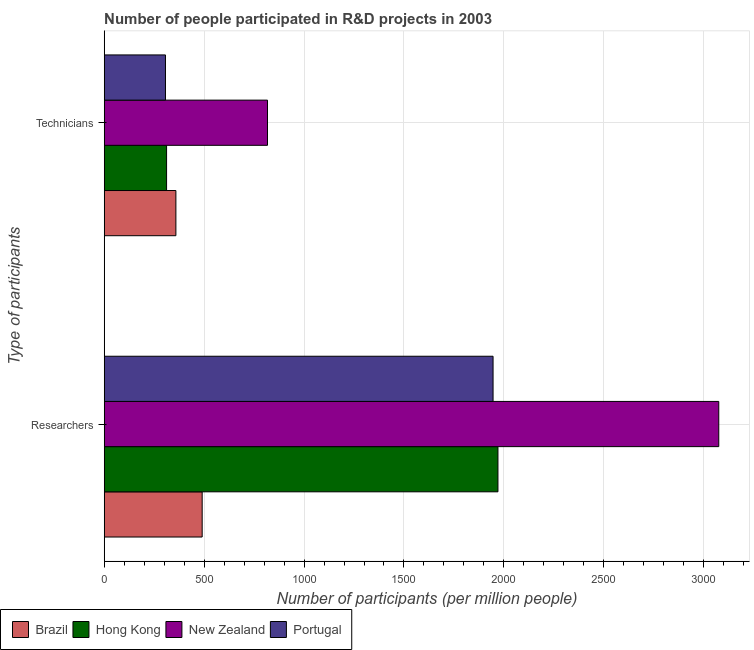How many different coloured bars are there?
Offer a very short reply. 4. Are the number of bars per tick equal to the number of legend labels?
Keep it short and to the point. Yes. What is the label of the 1st group of bars from the top?
Give a very brief answer. Technicians. What is the number of technicians in Brazil?
Make the answer very short. 358.64. Across all countries, what is the maximum number of technicians?
Provide a short and direct response. 817.12. Across all countries, what is the minimum number of researchers?
Ensure brevity in your answer.  490.22. In which country was the number of researchers maximum?
Give a very brief answer. New Zealand. In which country was the number of technicians minimum?
Offer a very short reply. Portugal. What is the total number of technicians in the graph?
Provide a short and direct response. 1794.44. What is the difference between the number of researchers in New Zealand and that in Brazil?
Ensure brevity in your answer.  2585. What is the difference between the number of technicians in Hong Kong and the number of researchers in Brazil?
Your answer should be very brief. -178.12. What is the average number of technicians per country?
Your answer should be compact. 448.61. What is the difference between the number of researchers and number of technicians in Brazil?
Keep it short and to the point. 131.58. What is the ratio of the number of technicians in Portugal to that in Hong Kong?
Make the answer very short. 0.98. Is the number of researchers in Brazil less than that in Hong Kong?
Your answer should be compact. Yes. What does the 3rd bar from the top in Technicians represents?
Provide a short and direct response. Hong Kong. What does the 3rd bar from the bottom in Researchers represents?
Provide a succinct answer. New Zealand. How many countries are there in the graph?
Give a very brief answer. 4. Does the graph contain grids?
Give a very brief answer. Yes. Where does the legend appear in the graph?
Make the answer very short. Bottom left. How are the legend labels stacked?
Your answer should be compact. Horizontal. What is the title of the graph?
Provide a short and direct response. Number of people participated in R&D projects in 2003. What is the label or title of the X-axis?
Provide a short and direct response. Number of participants (per million people). What is the label or title of the Y-axis?
Give a very brief answer. Type of participants. What is the Number of participants (per million people) of Brazil in Researchers?
Give a very brief answer. 490.22. What is the Number of participants (per million people) of Hong Kong in Researchers?
Make the answer very short. 1970.26. What is the Number of participants (per million people) in New Zealand in Researchers?
Your answer should be very brief. 3075.22. What is the Number of participants (per million people) of Portugal in Researchers?
Make the answer very short. 1945.82. What is the Number of participants (per million people) of Brazil in Technicians?
Your answer should be very brief. 358.64. What is the Number of participants (per million people) of Hong Kong in Technicians?
Offer a very short reply. 312.1. What is the Number of participants (per million people) in New Zealand in Technicians?
Provide a succinct answer. 817.12. What is the Number of participants (per million people) in Portugal in Technicians?
Ensure brevity in your answer.  306.57. Across all Type of participants, what is the maximum Number of participants (per million people) of Brazil?
Ensure brevity in your answer.  490.22. Across all Type of participants, what is the maximum Number of participants (per million people) in Hong Kong?
Provide a short and direct response. 1970.26. Across all Type of participants, what is the maximum Number of participants (per million people) of New Zealand?
Ensure brevity in your answer.  3075.22. Across all Type of participants, what is the maximum Number of participants (per million people) of Portugal?
Offer a very short reply. 1945.82. Across all Type of participants, what is the minimum Number of participants (per million people) in Brazil?
Make the answer very short. 358.64. Across all Type of participants, what is the minimum Number of participants (per million people) of Hong Kong?
Ensure brevity in your answer.  312.1. Across all Type of participants, what is the minimum Number of participants (per million people) of New Zealand?
Ensure brevity in your answer.  817.12. Across all Type of participants, what is the minimum Number of participants (per million people) in Portugal?
Offer a very short reply. 306.57. What is the total Number of participants (per million people) of Brazil in the graph?
Make the answer very short. 848.87. What is the total Number of participants (per million people) of Hong Kong in the graph?
Your response must be concise. 2282.36. What is the total Number of participants (per million people) of New Zealand in the graph?
Ensure brevity in your answer.  3892.35. What is the total Number of participants (per million people) of Portugal in the graph?
Your response must be concise. 2252.39. What is the difference between the Number of participants (per million people) of Brazil in Researchers and that in Technicians?
Provide a short and direct response. 131.58. What is the difference between the Number of participants (per million people) in Hong Kong in Researchers and that in Technicians?
Your response must be concise. 1658.16. What is the difference between the Number of participants (per million people) in New Zealand in Researchers and that in Technicians?
Offer a terse response. 2258.1. What is the difference between the Number of participants (per million people) in Portugal in Researchers and that in Technicians?
Keep it short and to the point. 1639.24. What is the difference between the Number of participants (per million people) in Brazil in Researchers and the Number of participants (per million people) in Hong Kong in Technicians?
Ensure brevity in your answer.  178.12. What is the difference between the Number of participants (per million people) of Brazil in Researchers and the Number of participants (per million people) of New Zealand in Technicians?
Keep it short and to the point. -326.9. What is the difference between the Number of participants (per million people) in Brazil in Researchers and the Number of participants (per million people) in Portugal in Technicians?
Your answer should be compact. 183.65. What is the difference between the Number of participants (per million people) of Hong Kong in Researchers and the Number of participants (per million people) of New Zealand in Technicians?
Keep it short and to the point. 1153.14. What is the difference between the Number of participants (per million people) in Hong Kong in Researchers and the Number of participants (per million people) in Portugal in Technicians?
Ensure brevity in your answer.  1663.69. What is the difference between the Number of participants (per million people) in New Zealand in Researchers and the Number of participants (per million people) in Portugal in Technicians?
Your answer should be compact. 2768.65. What is the average Number of participants (per million people) of Brazil per Type of participants?
Your response must be concise. 424.43. What is the average Number of participants (per million people) in Hong Kong per Type of participants?
Make the answer very short. 1141.18. What is the average Number of participants (per million people) of New Zealand per Type of participants?
Your response must be concise. 1946.17. What is the average Number of participants (per million people) of Portugal per Type of participants?
Your answer should be very brief. 1126.19. What is the difference between the Number of participants (per million people) in Brazil and Number of participants (per million people) in Hong Kong in Researchers?
Offer a very short reply. -1480.04. What is the difference between the Number of participants (per million people) in Brazil and Number of participants (per million people) in New Zealand in Researchers?
Offer a terse response. -2585. What is the difference between the Number of participants (per million people) of Brazil and Number of participants (per million people) of Portugal in Researchers?
Give a very brief answer. -1455.59. What is the difference between the Number of participants (per million people) of Hong Kong and Number of participants (per million people) of New Zealand in Researchers?
Offer a terse response. -1104.96. What is the difference between the Number of participants (per million people) in Hong Kong and Number of participants (per million people) in Portugal in Researchers?
Offer a terse response. 24.45. What is the difference between the Number of participants (per million people) of New Zealand and Number of participants (per million people) of Portugal in Researchers?
Make the answer very short. 1129.41. What is the difference between the Number of participants (per million people) of Brazil and Number of participants (per million people) of Hong Kong in Technicians?
Keep it short and to the point. 46.54. What is the difference between the Number of participants (per million people) of Brazil and Number of participants (per million people) of New Zealand in Technicians?
Offer a very short reply. -458.48. What is the difference between the Number of participants (per million people) of Brazil and Number of participants (per million people) of Portugal in Technicians?
Your response must be concise. 52.07. What is the difference between the Number of participants (per million people) in Hong Kong and Number of participants (per million people) in New Zealand in Technicians?
Keep it short and to the point. -505.02. What is the difference between the Number of participants (per million people) of Hong Kong and Number of participants (per million people) of Portugal in Technicians?
Your response must be concise. 5.53. What is the difference between the Number of participants (per million people) of New Zealand and Number of participants (per million people) of Portugal in Technicians?
Ensure brevity in your answer.  510.55. What is the ratio of the Number of participants (per million people) of Brazil in Researchers to that in Technicians?
Ensure brevity in your answer.  1.37. What is the ratio of the Number of participants (per million people) in Hong Kong in Researchers to that in Technicians?
Provide a succinct answer. 6.31. What is the ratio of the Number of participants (per million people) in New Zealand in Researchers to that in Technicians?
Offer a very short reply. 3.76. What is the ratio of the Number of participants (per million people) of Portugal in Researchers to that in Technicians?
Your response must be concise. 6.35. What is the difference between the highest and the second highest Number of participants (per million people) in Brazil?
Offer a terse response. 131.58. What is the difference between the highest and the second highest Number of participants (per million people) of Hong Kong?
Provide a short and direct response. 1658.16. What is the difference between the highest and the second highest Number of participants (per million people) in New Zealand?
Make the answer very short. 2258.1. What is the difference between the highest and the second highest Number of participants (per million people) of Portugal?
Offer a very short reply. 1639.24. What is the difference between the highest and the lowest Number of participants (per million people) of Brazil?
Give a very brief answer. 131.58. What is the difference between the highest and the lowest Number of participants (per million people) of Hong Kong?
Offer a terse response. 1658.16. What is the difference between the highest and the lowest Number of participants (per million people) of New Zealand?
Offer a very short reply. 2258.1. What is the difference between the highest and the lowest Number of participants (per million people) of Portugal?
Provide a succinct answer. 1639.24. 